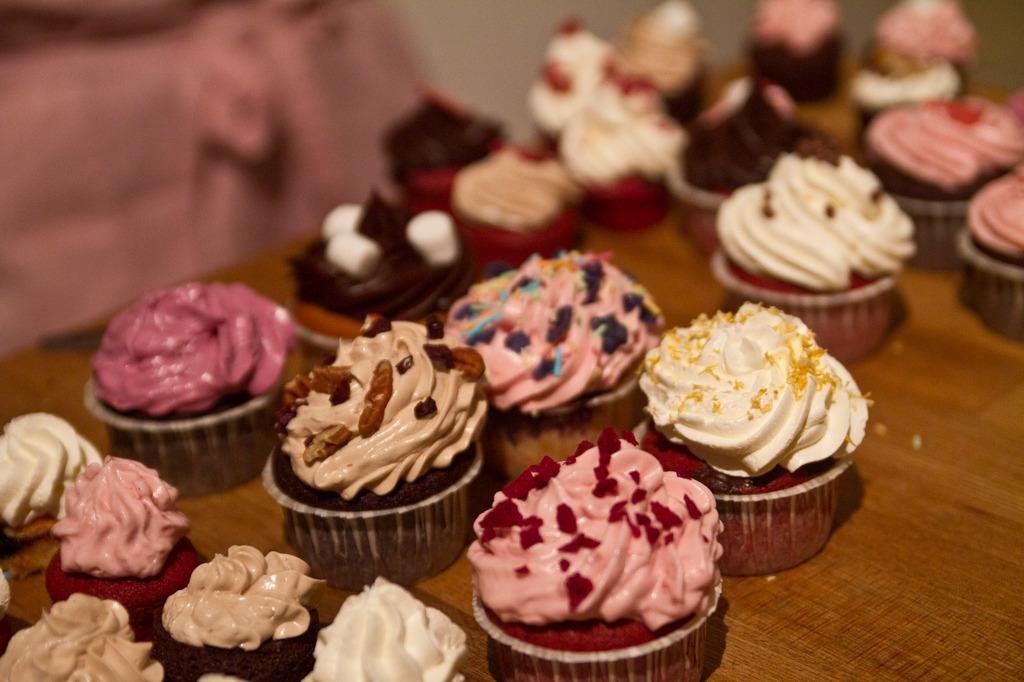What type of food can be seen in the image? There are cupcakes in the image. How many different colors can be seen on the cupcakes? The cupcakes are in different colors. What is the color of the table on which the cupcakes are placed? The cupcakes are on a brown table. Can you describe the background of the image? The background of the image is blurred. What historical event is being taught by the brothers in the image? There are no brothers or any teaching activity present in the image; it features cupcakes on a brown table with a blurred background. 